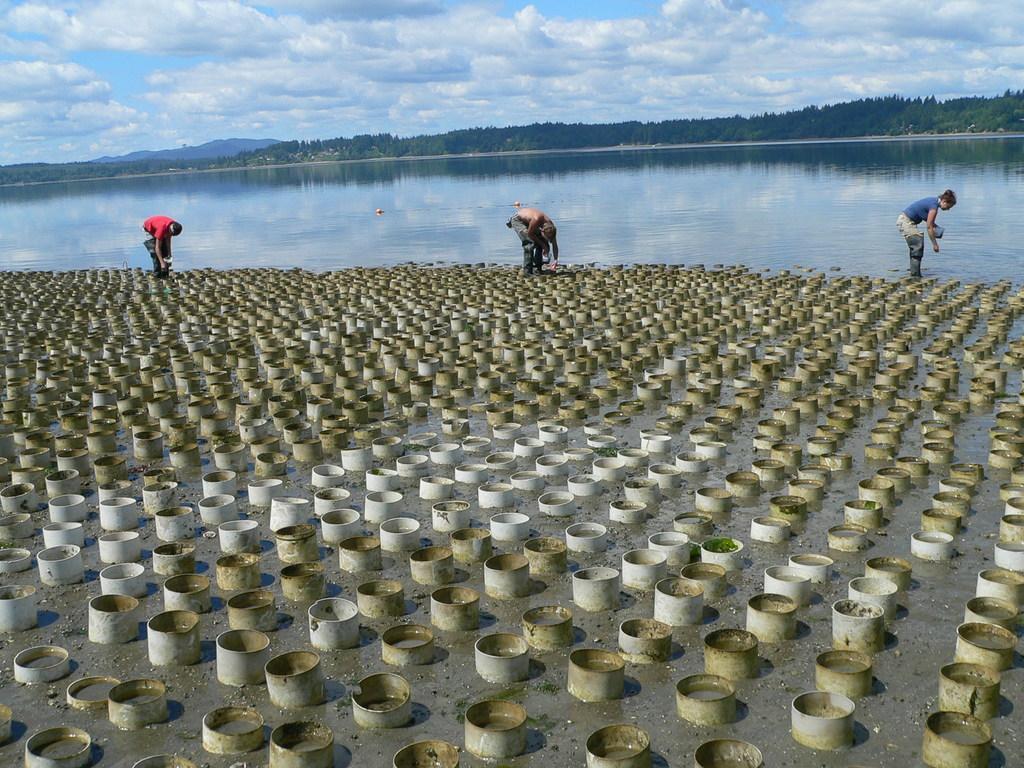Can you describe this image briefly? At the bottom of the image there is water, in the water three persons are standing and holding something in their hands and there are some pots. In the middle of the image there are some trees and hills. At the top of the image there are some clouds in the sky. 